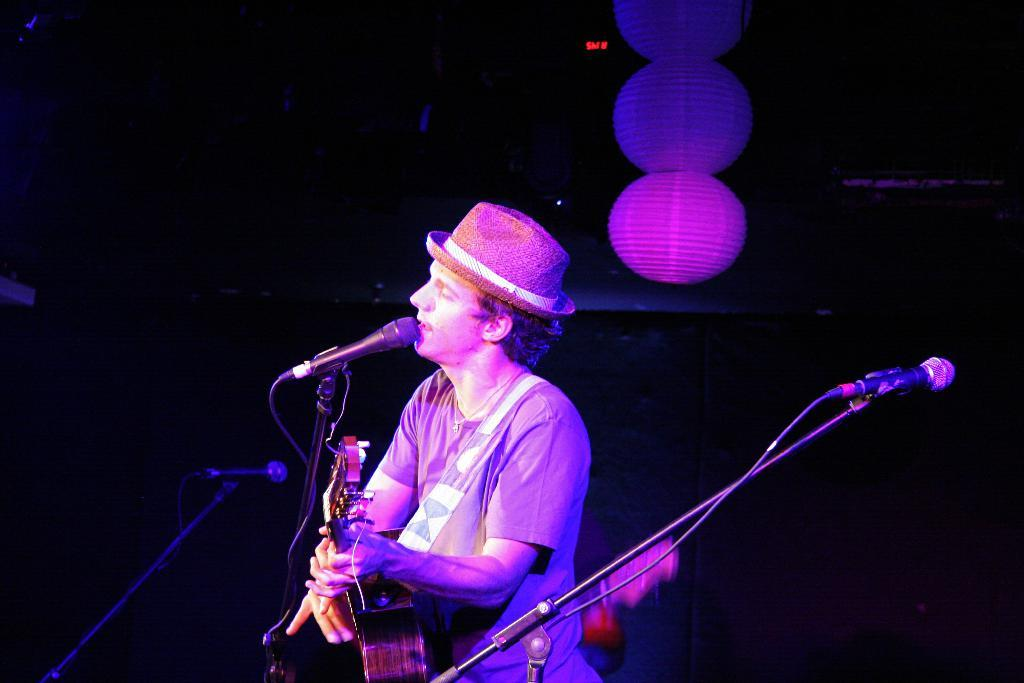What is the man in the image doing? The man is standing with a music instrument and singing into a microphone. What object is the man holding in the image? The man is holding a music instrument. What can be seen in the background of the image? There are white color balls in the background of the image. How does the man show respect to the waves in the image? There are no waves present in the image, so the man cannot show respect to them. 